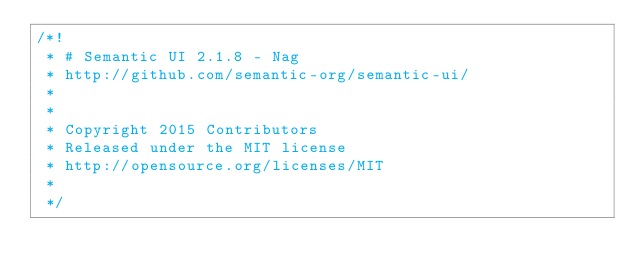<code> <loc_0><loc_0><loc_500><loc_500><_JavaScript_>/*!
 * # Semantic UI 2.1.8 - Nag
 * http://github.com/semantic-org/semantic-ui/
 *
 *
 * Copyright 2015 Contributors
 * Released under the MIT license
 * http://opensource.org/licenses/MIT
 *
 */</code> 